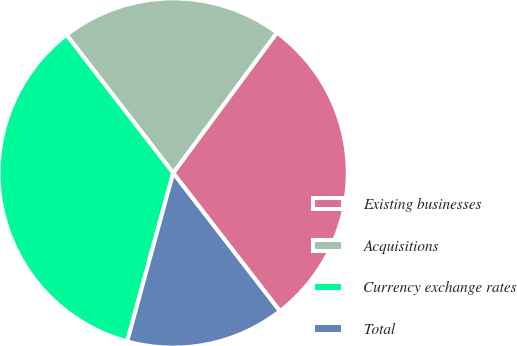<chart> <loc_0><loc_0><loc_500><loc_500><pie_chart><fcel>Existing businesses<fcel>Acquisitions<fcel>Currency exchange rates<fcel>Total<nl><fcel>29.41%<fcel>20.59%<fcel>35.29%<fcel>14.71%<nl></chart> 